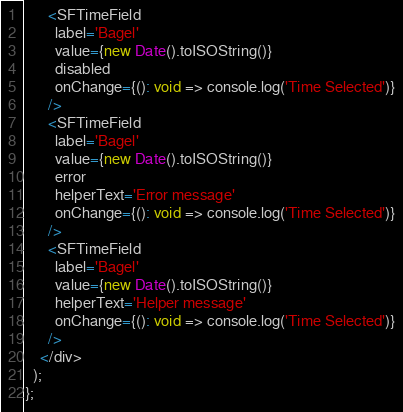Convert code to text. <code><loc_0><loc_0><loc_500><loc_500><_TypeScript_>      <SFTimeField
        label='Bagel'
        value={new Date().toISOString()}
        disabled
        onChange={(): void => console.log('Time Selected')}
      />
      <SFTimeField
        label='Bagel'
        value={new Date().toISOString()}
        error
        helperText='Error message'
        onChange={(): void => console.log('Time Selected')}
      />
      <SFTimeField
        label='Bagel'
        value={new Date().toISOString()}
        helperText='Helper message'
        onChange={(): void => console.log('Time Selected')}
      />
    </div>
  );
};
</code> 